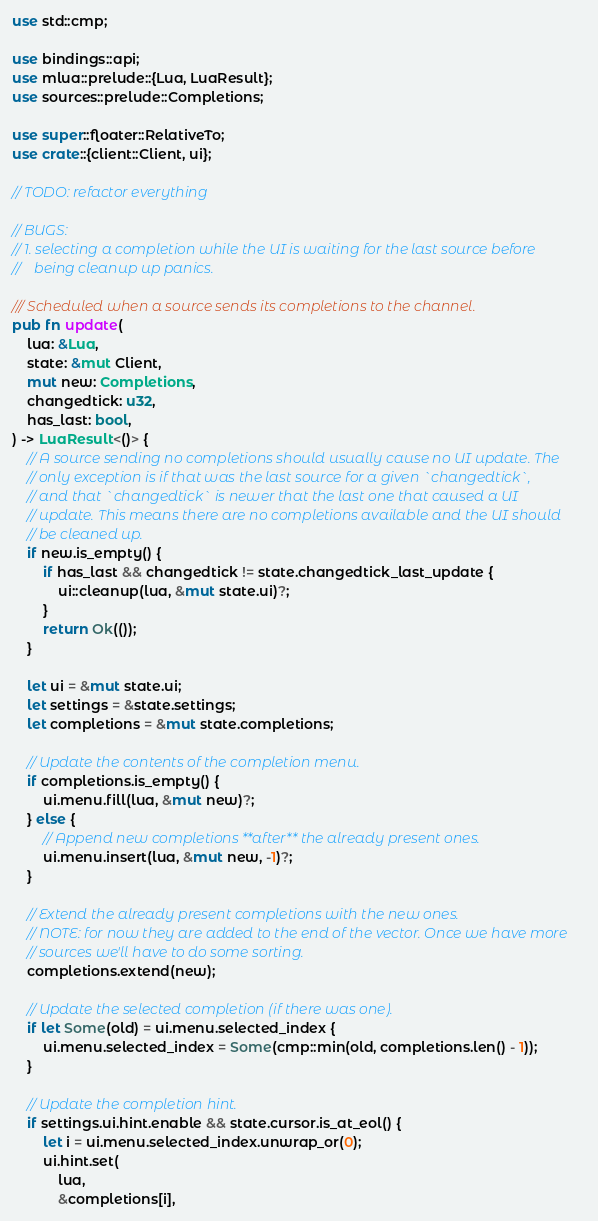<code> <loc_0><loc_0><loc_500><loc_500><_Rust_>use std::cmp;

use bindings::api;
use mlua::prelude::{Lua, LuaResult};
use sources::prelude::Completions;

use super::floater::RelativeTo;
use crate::{client::Client, ui};

// TODO: refactor everything

// BUGS:
// 1. selecting a completion while the UI is waiting for the last source before
//    being cleanup up panics.

/// Scheduled when a source sends its completions to the channel.
pub fn update(
    lua: &Lua,
    state: &mut Client,
    mut new: Completions,
    changedtick: u32,
    has_last: bool,
) -> LuaResult<()> {
    // A source sending no completions should usually cause no UI update. The
    // only exception is if that was the last source for a given `changedtick`,
    // and that `changedtick` is newer that the last one that caused a UI
    // update. This means there are no completions available and the UI should
    // be cleaned up.
    if new.is_empty() {
        if has_last && changedtick != state.changedtick_last_update {
            ui::cleanup(lua, &mut state.ui)?;
        }
        return Ok(());
    }

    let ui = &mut state.ui;
    let settings = &state.settings;
    let completions = &mut state.completions;

    // Update the contents of the completion menu.
    if completions.is_empty() {
        ui.menu.fill(lua, &mut new)?;
    } else {
        // Append new completions **after** the already present ones.
        ui.menu.insert(lua, &mut new, -1)?;
    }

    // Extend the already present completions with the new ones.
    // NOTE: for now they are added to the end of the vector. Once we have more
    // sources we'll have to do some sorting.
    completions.extend(new);

    // Update the selected completion (if there was one).
    if let Some(old) = ui.menu.selected_index {
        ui.menu.selected_index = Some(cmp::min(old, completions.len() - 1));
    }

    // Update the completion hint.
    if settings.ui.hint.enable && state.cursor.is_at_eol() {
        let i = ui.menu.selected_index.unwrap_or(0);
        ui.hint.set(
            lua,
            &completions[i],</code> 